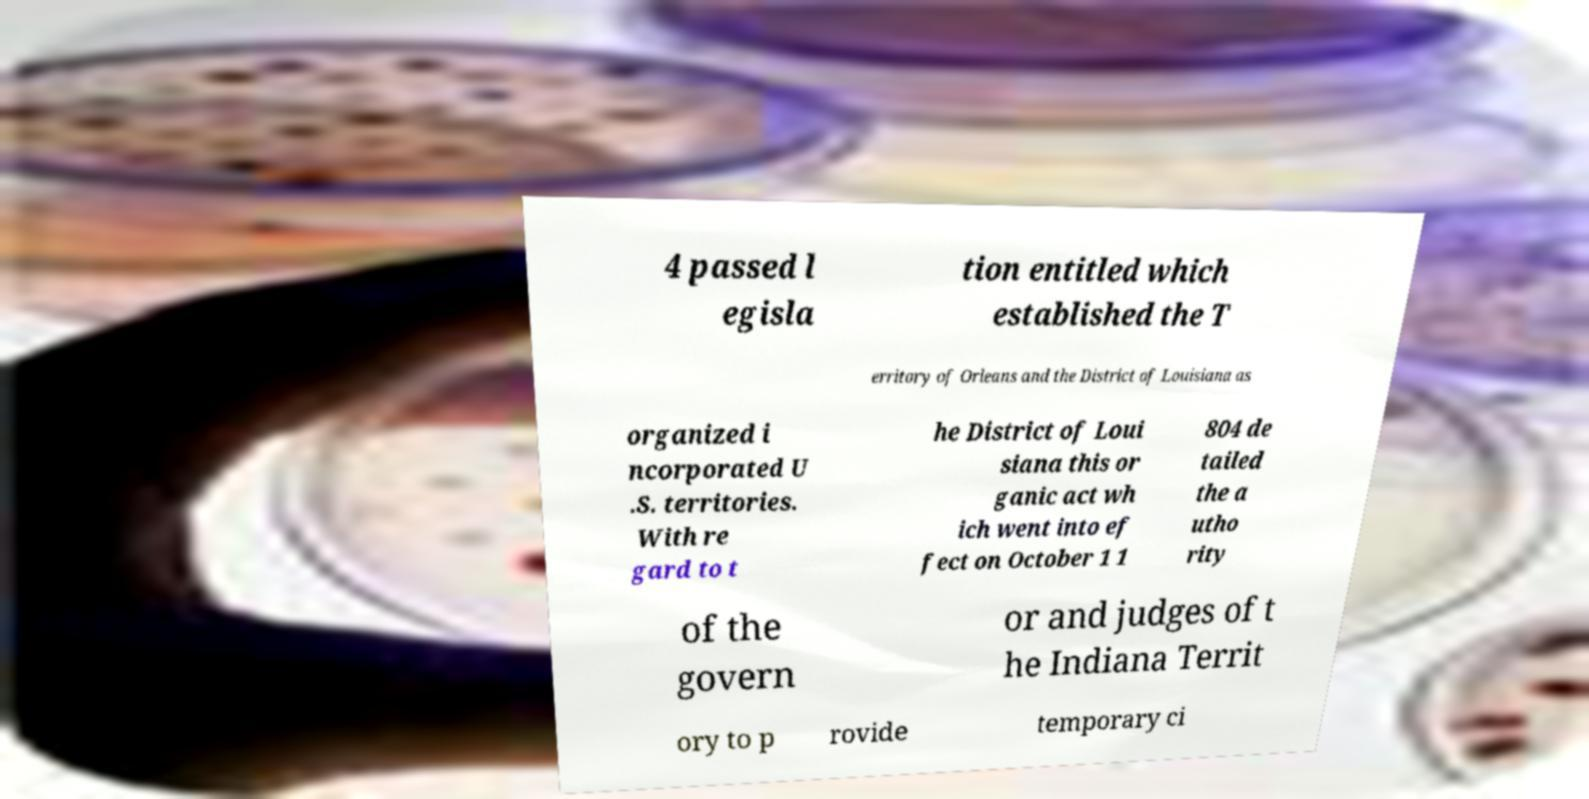Can you read and provide the text displayed in the image?This photo seems to have some interesting text. Can you extract and type it out for me? 4 passed l egisla tion entitled which established the T erritory of Orleans and the District of Louisiana as organized i ncorporated U .S. territories. With re gard to t he District of Loui siana this or ganic act wh ich went into ef fect on October 1 1 804 de tailed the a utho rity of the govern or and judges of t he Indiana Territ ory to p rovide temporary ci 